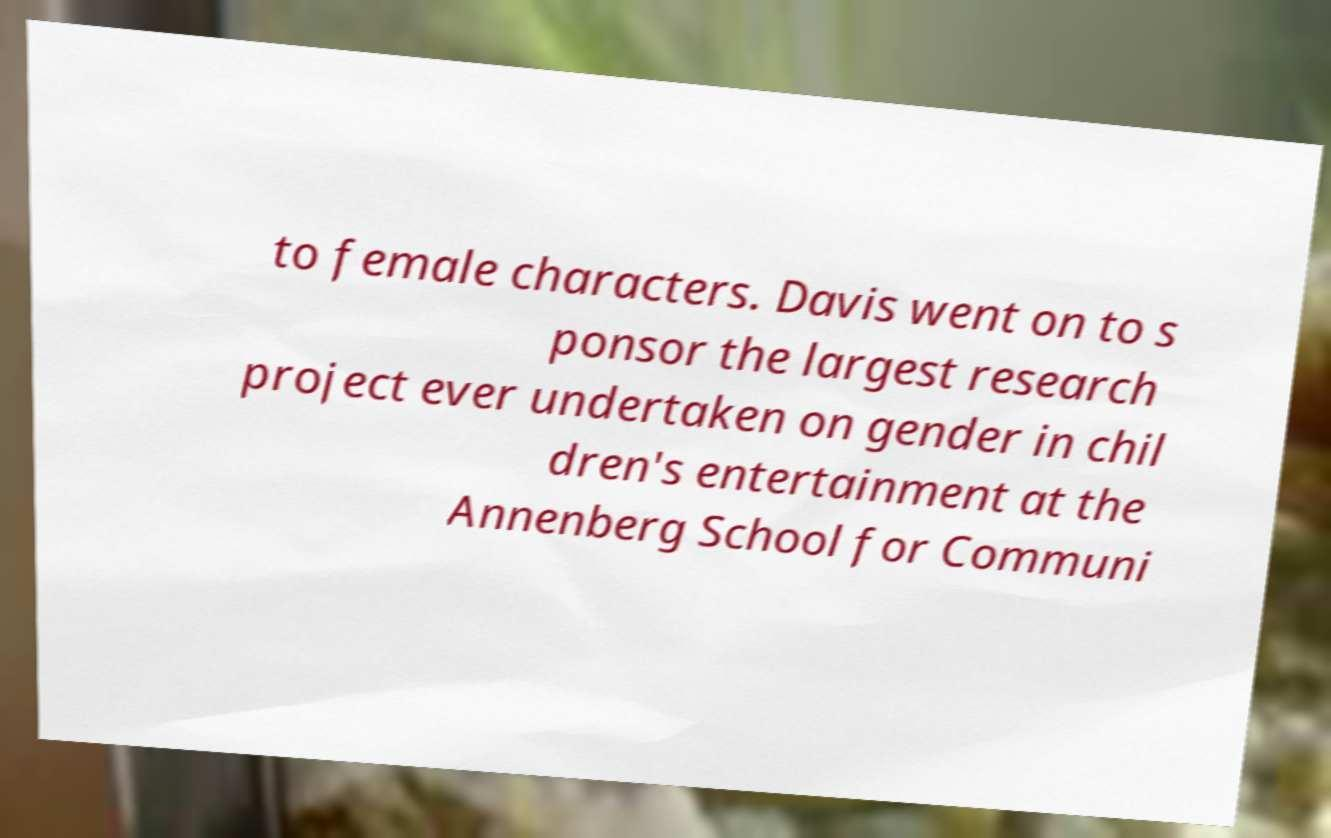For documentation purposes, I need the text within this image transcribed. Could you provide that? to female characters. Davis went on to s ponsor the largest research project ever undertaken on gender in chil dren's entertainment at the Annenberg School for Communi 